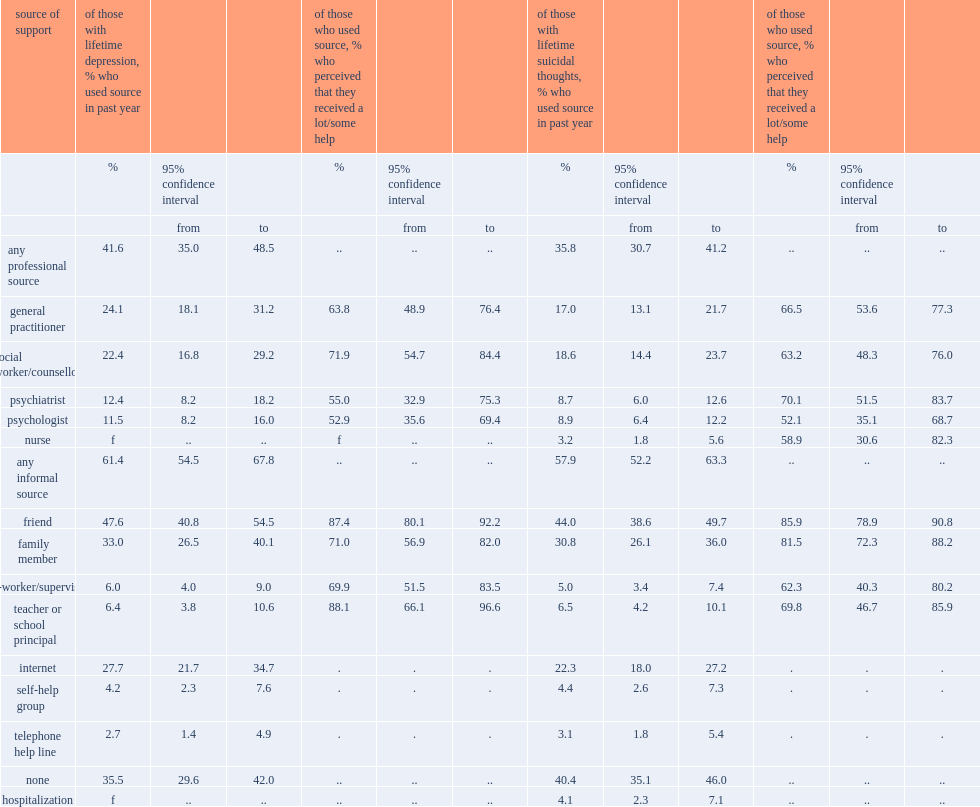Among 15- to 24-year-olds with lifetime depression,what are the percentages of those who consulted a professional and those who consulted an informal source in the past 12 months respectively? 41.6 61.4. List the top2 common informal sources and their percentages. Friend family member. Among those who reported lifetime suicidal thoughts,what are the percentages of those who consulted a professional and consulted an informal source respectively? 35.8 57.9. 